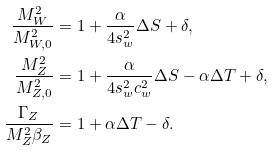Convert formula to latex. <formula><loc_0><loc_0><loc_500><loc_500>\frac { M _ { W } ^ { 2 } } { M _ { W , 0 } ^ { 2 } } & = 1 + \frac { \alpha } { 4 s _ { w } ^ { 2 } } \Delta S + \delta , \\ \frac { M _ { Z } ^ { 2 } } { M _ { Z , 0 } ^ { 2 } } & = 1 + \frac { \alpha } { 4 s _ { w } ^ { 2 } c _ { w } ^ { 2 } } \Delta S - \alpha \Delta T + \delta , \\ \frac { \Gamma _ { Z } } { M _ { Z } ^ { 2 } \beta _ { Z } } & = 1 + \alpha \Delta T - \delta .</formula> 